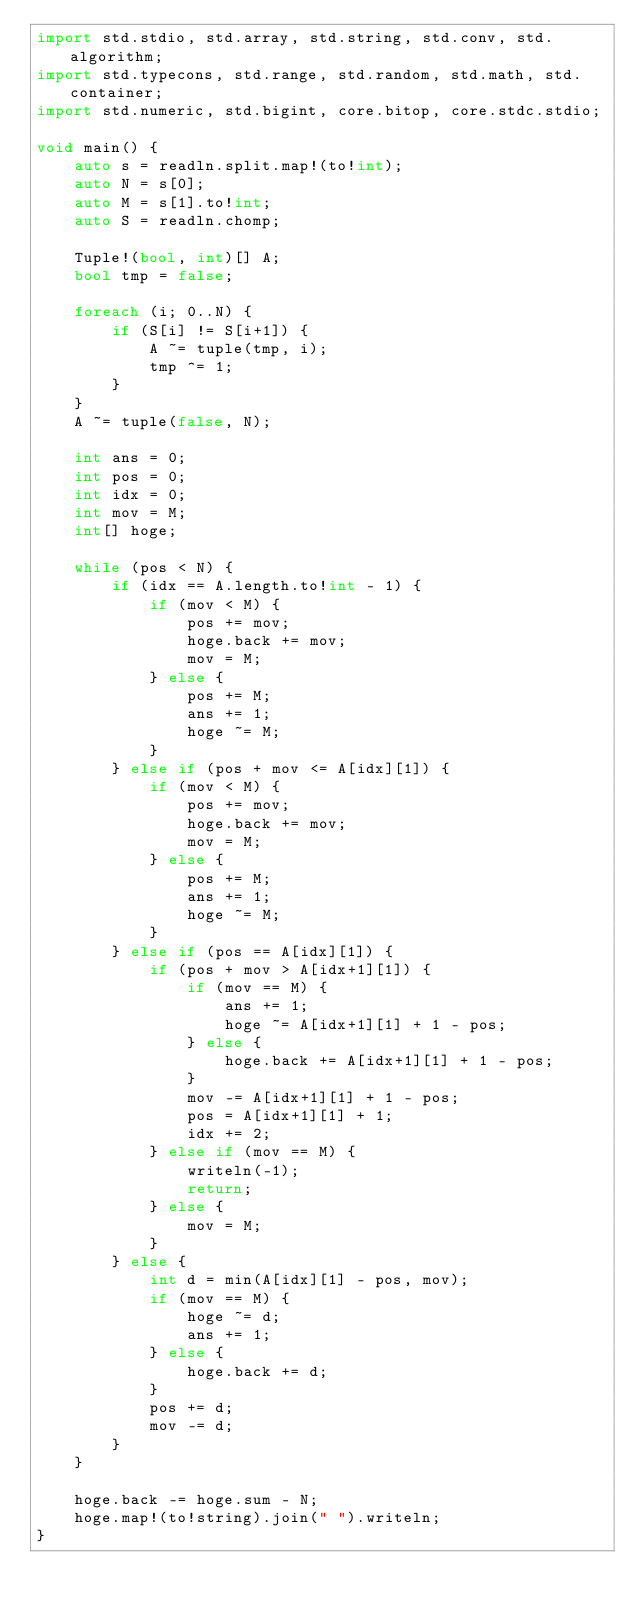<code> <loc_0><loc_0><loc_500><loc_500><_D_>import std.stdio, std.array, std.string, std.conv, std.algorithm;
import std.typecons, std.range, std.random, std.math, std.container;
import std.numeric, std.bigint, core.bitop, core.stdc.stdio;

void main() {
    auto s = readln.split.map!(to!int);
    auto N = s[0];
    auto M = s[1].to!int;
    auto S = readln.chomp;

    Tuple!(bool, int)[] A;
    bool tmp = false;

    foreach (i; 0..N) {
        if (S[i] != S[i+1]) {
            A ~= tuple(tmp, i);
            tmp ^= 1;
        }
    }
    A ~= tuple(false, N);

    int ans = 0;
    int pos = 0;
    int idx = 0;
    int mov = M;
    int[] hoge;

    while (pos < N) {
        if (idx == A.length.to!int - 1) {
            if (mov < M) {
                pos += mov;
                hoge.back += mov;
                mov = M;
            } else {
                pos += M;
                ans += 1;
                hoge ~= M;
            }
        } else if (pos + mov <= A[idx][1]) {
            if (mov < M) {
                pos += mov;
                hoge.back += mov;
                mov = M;
            } else {
                pos += M;
                ans += 1;
                hoge ~= M;
            }
        } else if (pos == A[idx][1]) {
            if (pos + mov > A[idx+1][1]) {
                if (mov == M) {
                    ans += 1;
                    hoge ~= A[idx+1][1] + 1 - pos;
                } else {
                    hoge.back += A[idx+1][1] + 1 - pos;
                }
                mov -= A[idx+1][1] + 1 - pos;
                pos = A[idx+1][1] + 1;
                idx += 2;
            } else if (mov == M) {
                writeln(-1);
                return;
            } else {
                mov = M;
            }
        } else {
            int d = min(A[idx][1] - pos, mov);
            if (mov == M) {
                hoge ~= d;
                ans += 1;
            } else {
                hoge.back += d;
            }
            pos += d;
            mov -= d;
        }
    }

    hoge.back -= hoge.sum - N;
    hoge.map!(to!string).join(" ").writeln;
}</code> 